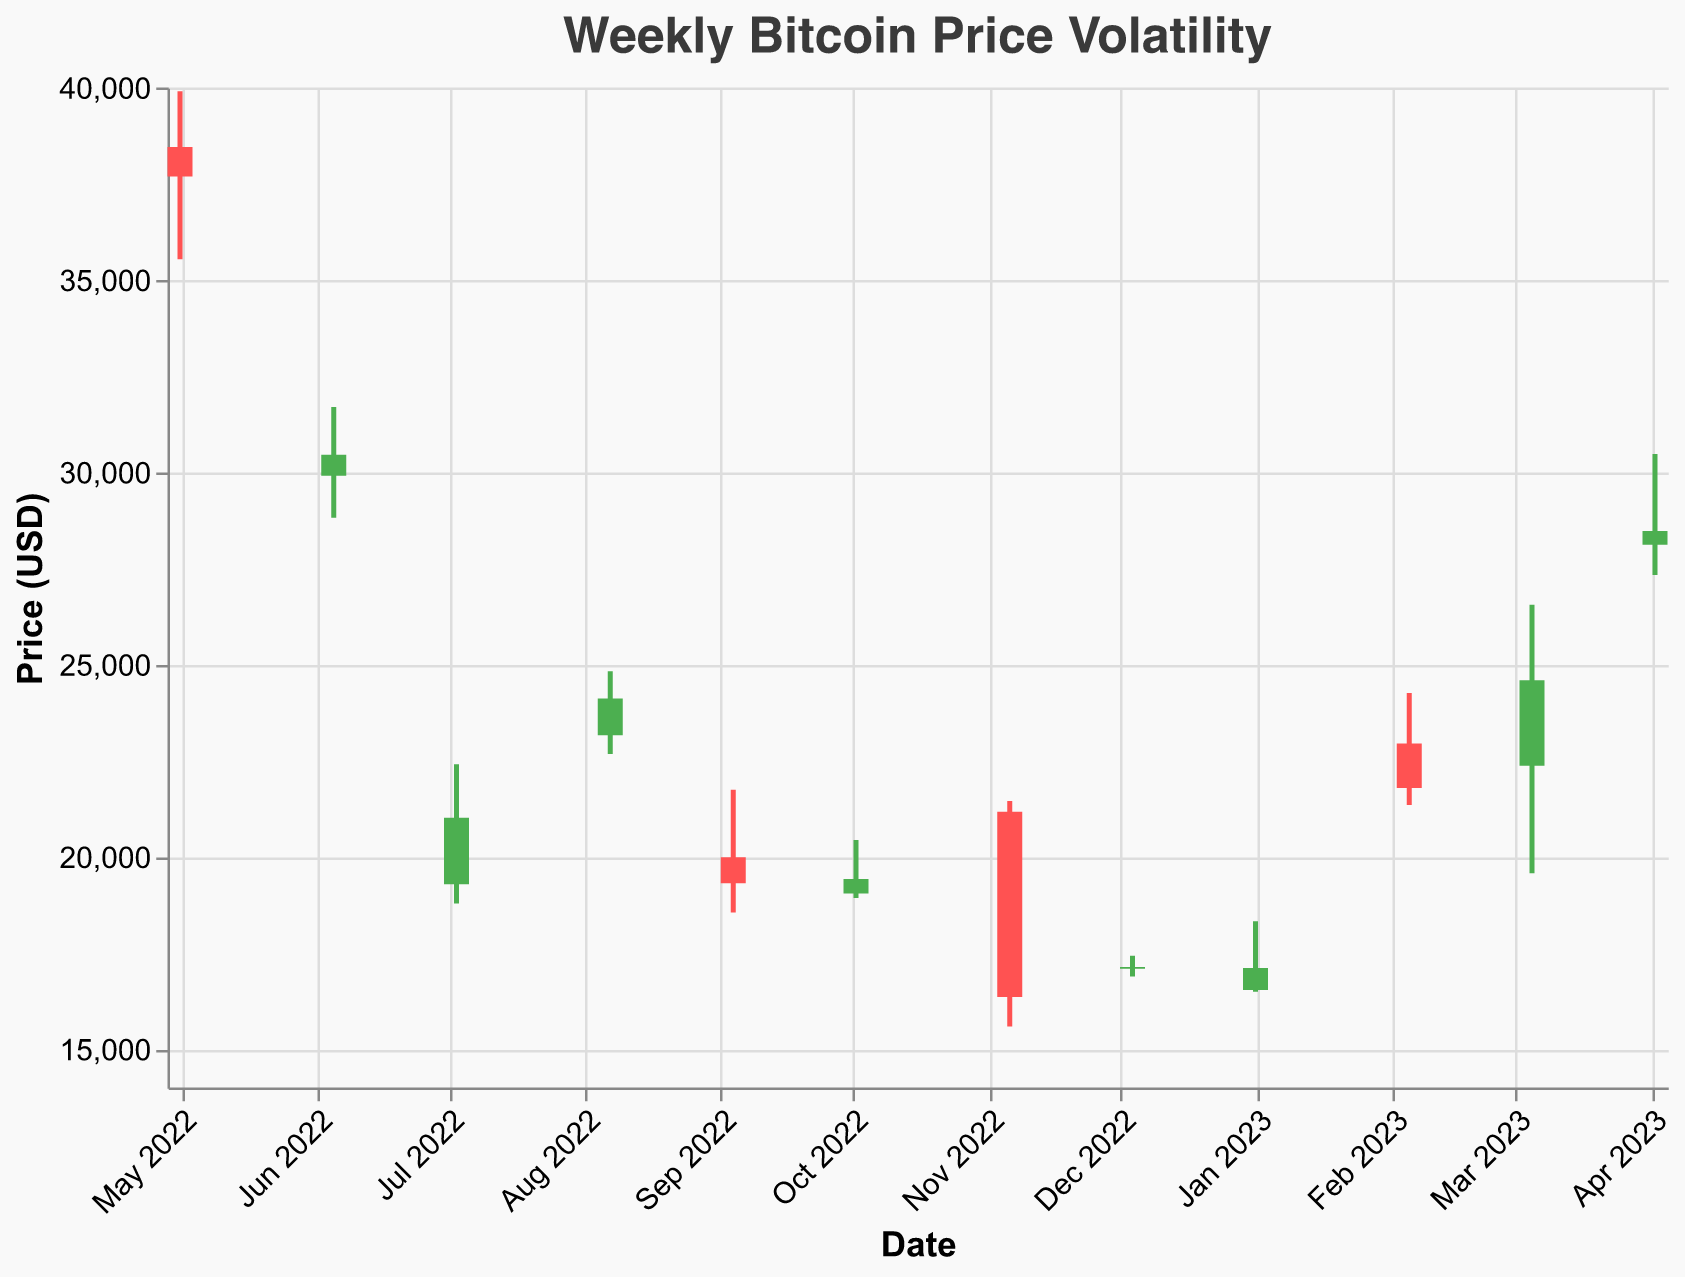What is the title of the chart? The title is usually located at the top of the chart. The title indicates the main topic of the chart. In this case, the title is "Weekly Bitcoin Price Volatility".
Answer: Weekly Bitcoin Price Volatility How many data points are shown in the chart? To find the number of data points, count the number of distinct dates on the x-axis. Here, every date represents a data point. There are 12 dates listed.
Answer: 12 Which date had the highest price for Bitcoin within the period shown? To locate the highest price, look for the data point with the highest value on the y-axis. The highest value is 30468.90 on the week starting April 02, 2023.
Answer: April 02, 2023 What was the opening price of Bitcoin on February 5, 2023? Find the bar corresponding to the date February 5, 2023, and look at the "Open" value. The "Open" value is shown as the bottom level of the vertical bar.
Answer: 22945.12 On which week did Bitcoin have the lowest closing price? To determine the lowest closing price, identify the smallest value at the top of the bars. The lowest closing price is 16353.12 on the week starting November 06, 2022.
Answer: November 06, 2022 Which weeks show a decrease in Bitcoin's closing price compared to the opening price? A decrease is shown by the color red in the bars. Count the red bars and note their corresponding dates. Dates with decreases are May 01, 2022, June 05, 2022, September 04, 2022, November 06, 2022, December 04, 2022, January 01, 2023, and February 05, 2023.
Answer: May 01, 2022; June 05, 2022; September 04, 2022; November 06, 2022; December 04, 2022; January 01, 2023; February 05, 2023 What is the range of Bitcoin prices on March 05, 2023? Calculate the range by subtracting the lowest price from the highest price on March 05, 2023. The lowest price is 19568.90, and the highest is 26553.78. The range is 26553.78 - 19568.90 = 6984.88.
Answer: 6984.88 Which date experienced the greatest price volatility and how can you tell? Volatility is indicated by the length of the vertical line (difference between high and low prices). The longest vertical line corresponds to the greatest volatility. This occurs on November 06, 2022, with a high of 21446.90 and a low of 15588.23.
Answer: November 06, 2022 What is the average closing price of Bitcoin for the given period? Sum all the closing prices and divide by the number of data points. The sum is 37688.45 + 30450.22 + 21016.33 + 24116.20 + 19312.98 + 19419.45 + 16353.12 + 17130.56 + 17105.34 + 21789.45 + 24590.12 + 28469.78 = 277442.00. Dividing by 12 gives 277442.00 / 12 = 23120.17.
Answer: 23120.17 